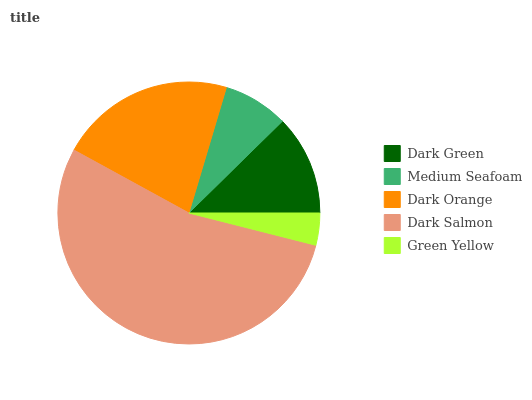Is Green Yellow the minimum?
Answer yes or no. Yes. Is Dark Salmon the maximum?
Answer yes or no. Yes. Is Medium Seafoam the minimum?
Answer yes or no. No. Is Medium Seafoam the maximum?
Answer yes or no. No. Is Dark Green greater than Medium Seafoam?
Answer yes or no. Yes. Is Medium Seafoam less than Dark Green?
Answer yes or no. Yes. Is Medium Seafoam greater than Dark Green?
Answer yes or no. No. Is Dark Green less than Medium Seafoam?
Answer yes or no. No. Is Dark Green the high median?
Answer yes or no. Yes. Is Dark Green the low median?
Answer yes or no. Yes. Is Medium Seafoam the high median?
Answer yes or no. No. Is Medium Seafoam the low median?
Answer yes or no. No. 